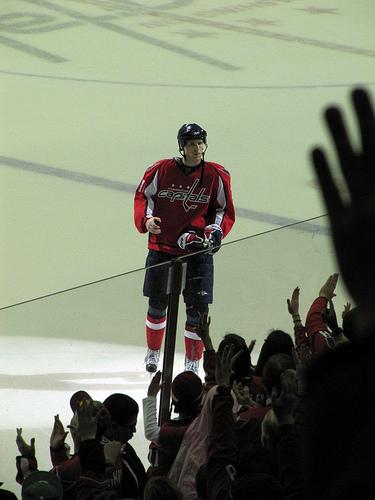<image>
Is there a helmet behind the man? No. The helmet is not behind the man. From this viewpoint, the helmet appears to be positioned elsewhere in the scene. 